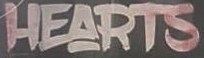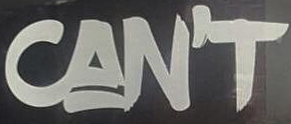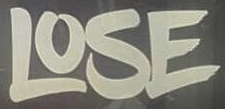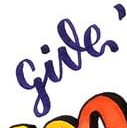What text appears in these images from left to right, separated by a semicolon? HEARTS; CAN'T; LOSE; give 